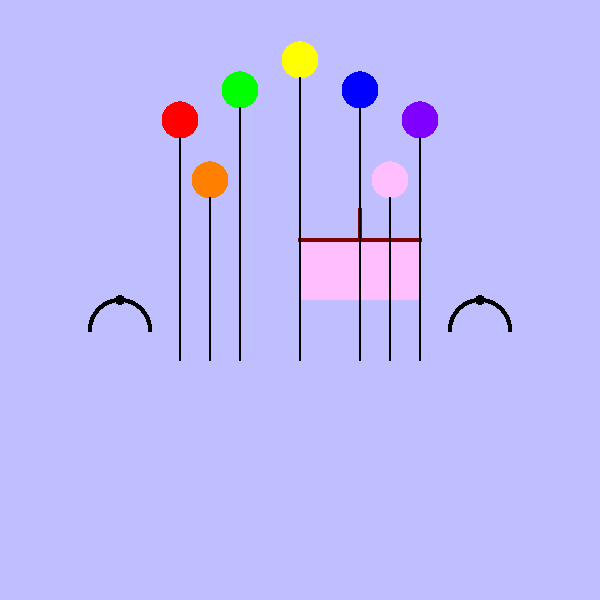At this cheerful birthday party, how many colorful balloons are floating above the cake? To find the number of balloons at this cheerful birthday party, let's count them step by step:

1. First, we see a row of balloons at the top of the image:
   - There are 5 balloons in this row (red, green, yellow, blue, and purple)

2. Below this row, we can see two more balloons:
   - One orange balloon on the left
   - One pink balloon on the right

3. To get the total number of balloons, we add all the balloons we've counted:
   $5 + 2 = 7$

Therefore, there are 7 colorful balloons floating above the cake at this cheerful birthday party.
Answer: 7 